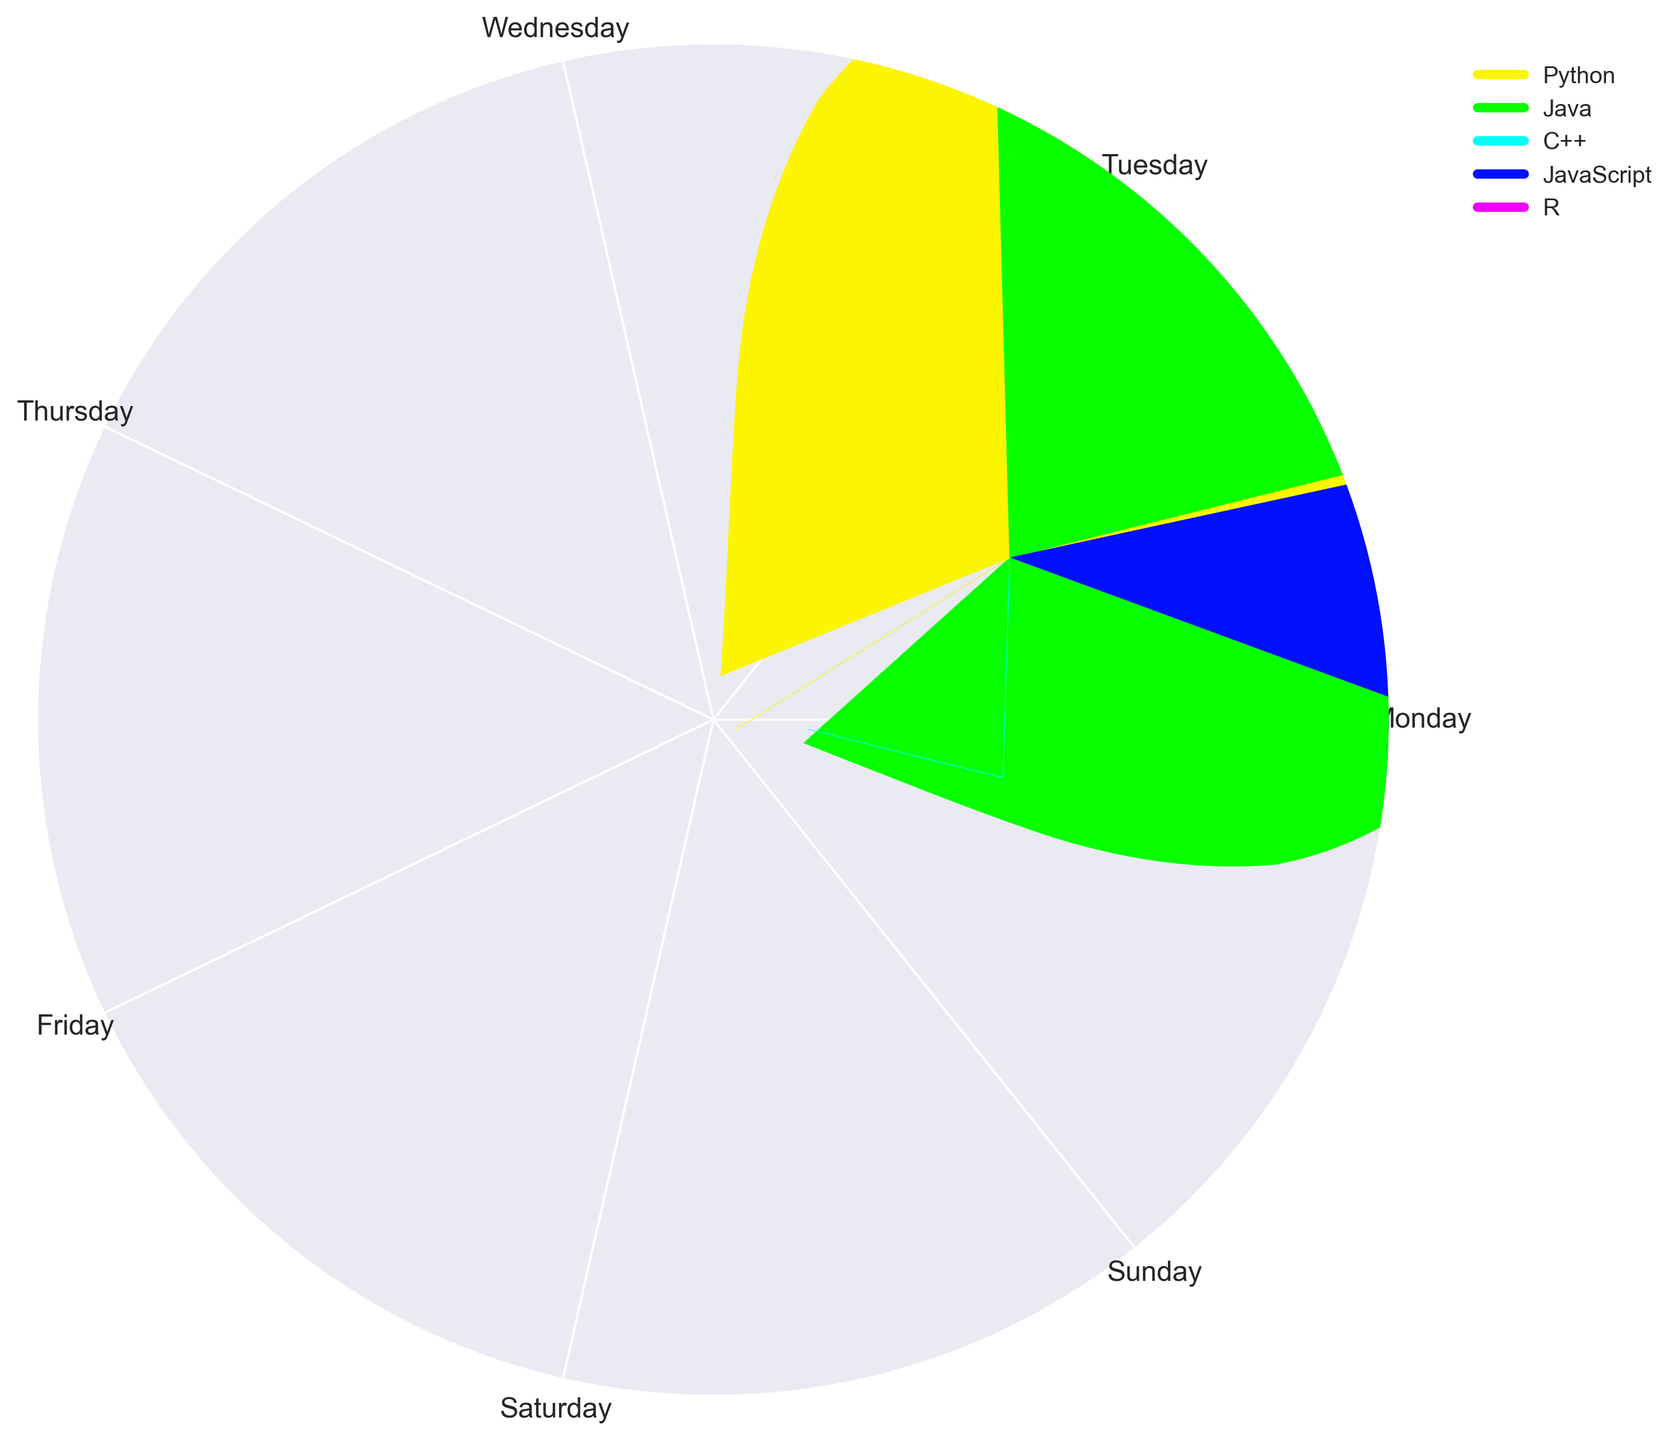Which day has the highest number of hours spent on Python? To identify the day with the highest usage of Python, look for the longest segment in Python's color (identified in the legend) across all days. Observe that Friday has the longest segment for Python.
Answer: Friday Which language is used for the most number of hours on Wednesday? Locate Wednesday on the circular chart and check which segment is the largest. The largest segment corresponds to Java, as the segment extends further than others.
Answer: Java Compare the usage patterns of JavaScript on Tuesday and Sunday. On which day is JavaScript used more? Check the segments for JavaScript (identified in the legend) on Tuesday and Sunday. On Tuesday, JavaScript's segment covers 2 hours, and on Sunday, it covers 1 hour.
Answer: Tuesday What is the total number of hours spent on Java throughout the week? Sum the height (or length of the segments) of Java across all days. Java is used for 2 hours (Monday) + 1 hour (Tuesday) + 3 hours (Wednesday) + 2 hours (Thursday) + 1 hour (Friday) + 2 hours (Saturday) + 2 hours (Sunday) = 13 hours.
Answer: 13 How does the total usage of Python compare to the total usage of JavaScript over the week? Sum the heights of segments for Python and JavaScript and compare. For Python: 3 (Monday) + 4 (Tuesday) + 2 (Wednesday) + 3 (Thursday) + 4 (Friday) + 2 (Saturday) + 3 (Sunday) = 21 hours. For JavaScript: 0 (Monday) + 2 (Tuesday) + 0 (Wednesday) + 0 (Thursday) + 2 (Friday) + 0 (Saturday) + 1 (Sunday) = 5 hours. Python usage is higher than JavaScript.
Answer: Python > JavaScript Which language is used the least on Thursday? Identify Thursday in the chart and observe the smallest segment. The segment for R is the smallest with only 1 hour.
Answer: R Does the usage pattern of C++ exhibit any trend through the week? Track the segment height for C++ across all days. On Monday: 1 hour, Wednesday: 1 hour, Saturday: 1 hour. No usage on other days indicates an inconsistent trend with presence only on Monday, Wednesday, and Saturday.
Answer: Inconsistent Which two days have the highest combined hours spent on Python and JavaScript? Identify individual day totals for Python and JavaScript and find the two days with the highest combined totals. Friday has 4 (Python) + 2 (JavaScript) = 6 hours. Sunday has 3 (Python) + 1 (JavaScript) = 4 hours. Tuesday has 4 (Python) + 2 (JavaScript) = 6 hours. Tuesday and Friday have the most at 6 hours.
Answer: Tuesday and Friday 